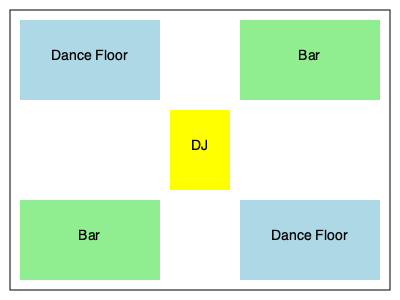In a medium-sized club with a capacity of 200 people, which layout configuration would be most effective for maximizing dance floor space while ensuring easy access to the bar and maintaining crowd flow? To determine the most effective layout for a medium-sized club, we need to consider several factors:

1. Dance floor space: The primary focus for dance enthusiasts should be a spacious dance floor.
2. Bar accessibility: Patrons should have easy access to the bar without disrupting dancers.
3. Crowd flow: The layout should allow for smooth movement between areas.
4. DJ visibility: The DJ booth should be centrally located for optimal sound distribution and visibility.

Analyzing the given floor plan:

a) The layout features two dance floors (light blue areas) and two bar areas (light green areas).
b) The DJ booth (yellow) is centrally located, providing good visibility and sound distribution to both dance floors.
c) Having two separate dance floors allows for different music styles or energy levels in each area.
d) The bar areas are positioned diagonally opposite each other, ensuring easy access from both dance floors.
e) This configuration creates a circular flow around the central DJ booth, facilitating movement between all areas.

For a medium-sized club with 200 people capacity:

1. Total floor space: Assuming 4 sq ft per person, we need at least 800 sq ft.
2. Dance floor size: Allocating 50% of the space for dancing, we need 400 sq ft for dance floors.
3. Bar area: Allocating 25% of the space for bars, we need 200 sq ft for bar areas.
4. Remaining space: 25% for walkways, DJ booth, and other amenities.

The layout in the diagram efficiently utilizes the available space while meeting these requirements. It provides two separate dance floors, totaling approximately 50% of the club's area, with easy access to two bar areas. The central DJ booth creates a focal point and helps maintain crowd flow.
Answer: Two diagonal dance floors with centrally located DJ booth and opposite corner bars 